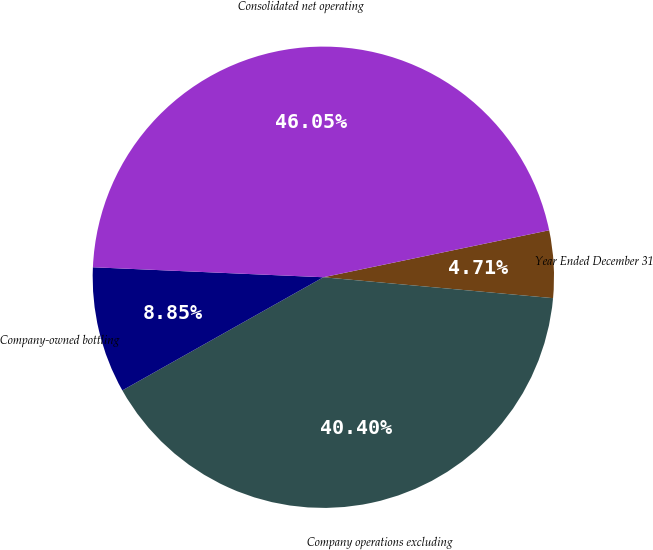<chart> <loc_0><loc_0><loc_500><loc_500><pie_chart><fcel>Year Ended December 31<fcel>Company operations excluding<fcel>Company-owned bottling<fcel>Consolidated net operating<nl><fcel>4.71%<fcel>40.4%<fcel>8.85%<fcel>46.05%<nl></chart> 